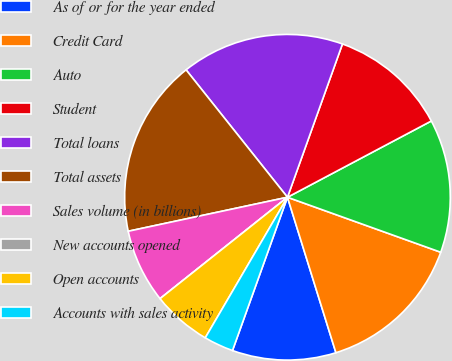Convert chart. <chart><loc_0><loc_0><loc_500><loc_500><pie_chart><fcel>As of or for the year ended<fcel>Credit Card<fcel>Auto<fcel>Student<fcel>Total loans<fcel>Total assets<fcel>Sales volume (in billions)<fcel>New accounts opened<fcel>Open accounts<fcel>Accounts with sales activity<nl><fcel>10.29%<fcel>14.71%<fcel>13.24%<fcel>11.76%<fcel>16.18%<fcel>17.65%<fcel>7.35%<fcel>0.0%<fcel>5.88%<fcel>2.94%<nl></chart> 